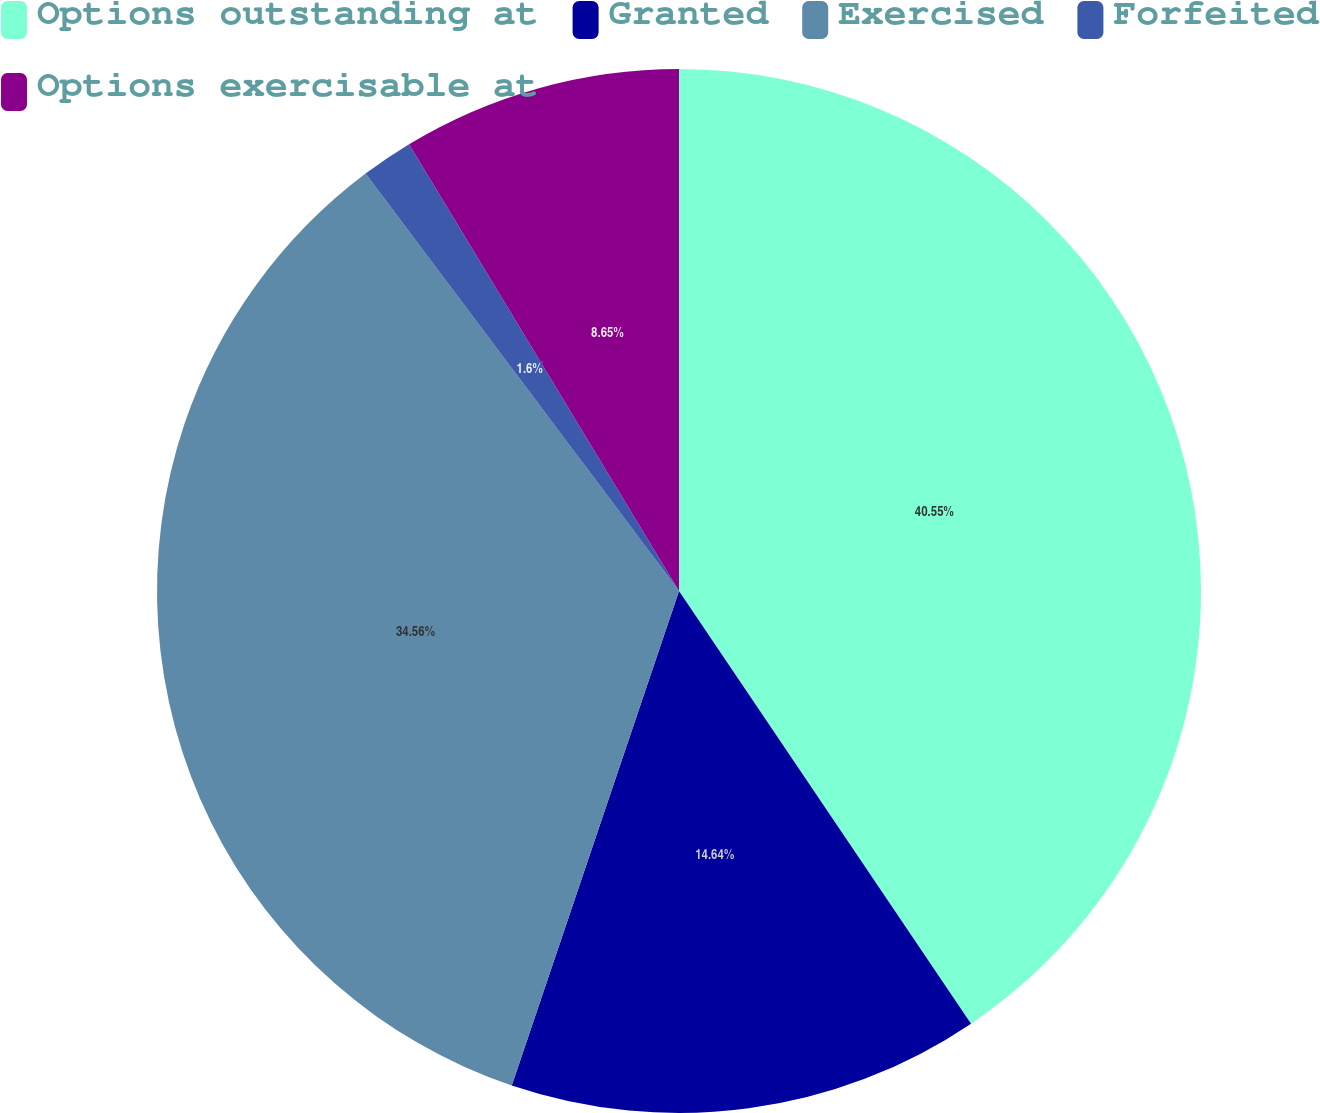Convert chart to OTSL. <chart><loc_0><loc_0><loc_500><loc_500><pie_chart><fcel>Options outstanding at<fcel>Granted<fcel>Exercised<fcel>Forfeited<fcel>Options exercisable at<nl><fcel>40.55%<fcel>14.64%<fcel>34.56%<fcel>1.6%<fcel>8.65%<nl></chart> 